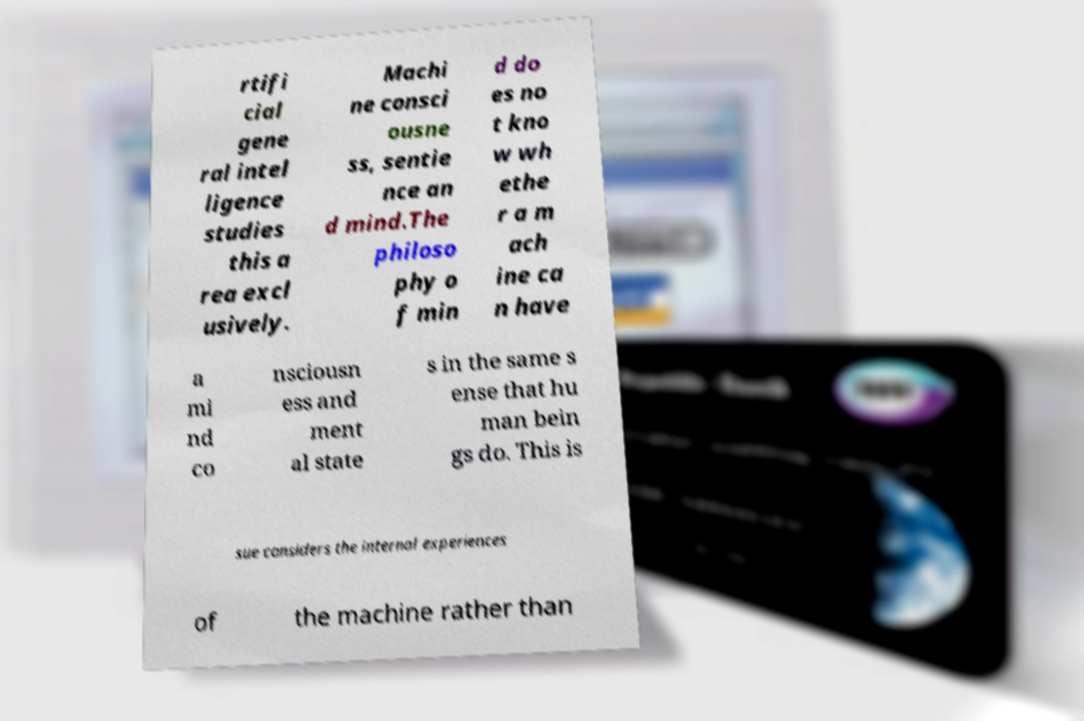Could you assist in decoding the text presented in this image and type it out clearly? rtifi cial gene ral intel ligence studies this a rea excl usively. Machi ne consci ousne ss, sentie nce an d mind.The philoso phy o f min d do es no t kno w wh ethe r a m ach ine ca n have a mi nd co nsciousn ess and ment al state s in the same s ense that hu man bein gs do. This is sue considers the internal experiences of the machine rather than 